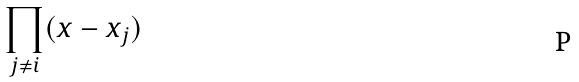<formula> <loc_0><loc_0><loc_500><loc_500>\prod _ { j \ne i } ( x - x _ { j } )</formula> 